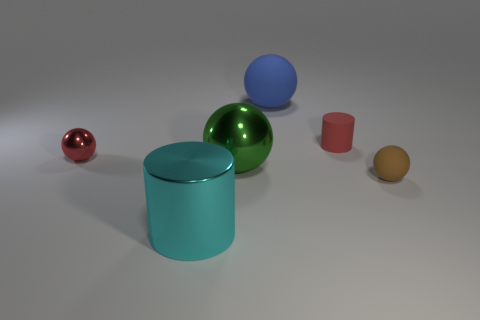What is the material of the tiny cylinder that is the same color as the tiny shiny sphere?
Make the answer very short. Rubber. What number of objects are green metal spheres that are in front of the big blue object or balls in front of the small red matte cylinder?
Offer a very short reply. 3. What is the size of the cylinder that is the same material as the green sphere?
Provide a succinct answer. Large. What number of metallic things are either red cylinders or green things?
Provide a short and direct response. 1. What size is the red matte cylinder?
Offer a very short reply. Small. Do the cyan metal cylinder and the blue ball have the same size?
Make the answer very short. Yes. There is a red thing that is right of the small metal thing; what is it made of?
Provide a succinct answer. Rubber. There is a big blue thing that is the same shape as the green metal object; what material is it?
Your answer should be compact. Rubber. Is there a blue sphere behind the rubber ball to the left of the small matte sphere?
Keep it short and to the point. No. Is the blue matte object the same shape as the big green object?
Provide a succinct answer. Yes. 